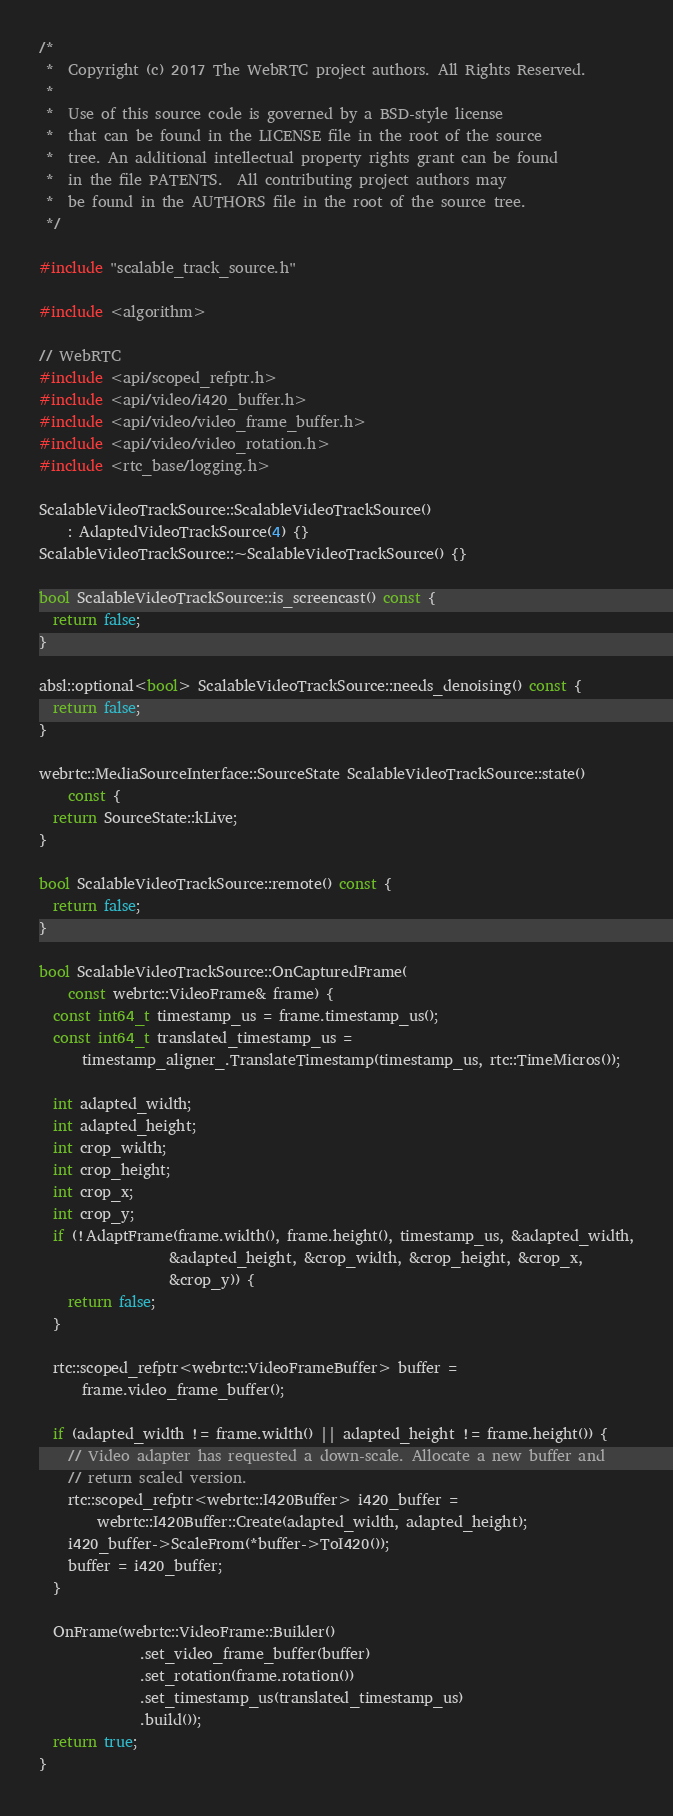Convert code to text. <code><loc_0><loc_0><loc_500><loc_500><_C++_>/*
 *  Copyright (c) 2017 The WebRTC project authors. All Rights Reserved.
 *
 *  Use of this source code is governed by a BSD-style license
 *  that can be found in the LICENSE file in the root of the source
 *  tree. An additional intellectual property rights grant can be found
 *  in the file PATENTS.  All contributing project authors may
 *  be found in the AUTHORS file in the root of the source tree.
 */

#include "scalable_track_source.h"

#include <algorithm>

// WebRTC
#include <api/scoped_refptr.h>
#include <api/video/i420_buffer.h>
#include <api/video/video_frame_buffer.h>
#include <api/video/video_rotation.h>
#include <rtc_base/logging.h>

ScalableVideoTrackSource::ScalableVideoTrackSource()
    : AdaptedVideoTrackSource(4) {}
ScalableVideoTrackSource::~ScalableVideoTrackSource() {}

bool ScalableVideoTrackSource::is_screencast() const {
  return false;
}

absl::optional<bool> ScalableVideoTrackSource::needs_denoising() const {
  return false;
}

webrtc::MediaSourceInterface::SourceState ScalableVideoTrackSource::state()
    const {
  return SourceState::kLive;
}

bool ScalableVideoTrackSource::remote() const {
  return false;
}

bool ScalableVideoTrackSource::OnCapturedFrame(
    const webrtc::VideoFrame& frame) {
  const int64_t timestamp_us = frame.timestamp_us();
  const int64_t translated_timestamp_us =
      timestamp_aligner_.TranslateTimestamp(timestamp_us, rtc::TimeMicros());

  int adapted_width;
  int adapted_height;
  int crop_width;
  int crop_height;
  int crop_x;
  int crop_y;
  if (!AdaptFrame(frame.width(), frame.height(), timestamp_us, &adapted_width,
                  &adapted_height, &crop_width, &crop_height, &crop_x,
                  &crop_y)) {
    return false;
  }

  rtc::scoped_refptr<webrtc::VideoFrameBuffer> buffer =
      frame.video_frame_buffer();

  if (adapted_width != frame.width() || adapted_height != frame.height()) {
    // Video adapter has requested a down-scale. Allocate a new buffer and
    // return scaled version.
    rtc::scoped_refptr<webrtc::I420Buffer> i420_buffer =
        webrtc::I420Buffer::Create(adapted_width, adapted_height);
    i420_buffer->ScaleFrom(*buffer->ToI420());
    buffer = i420_buffer;
  }

  OnFrame(webrtc::VideoFrame::Builder()
              .set_video_frame_buffer(buffer)
              .set_rotation(frame.rotation())
              .set_timestamp_us(translated_timestamp_us)
              .build());
  return true;
}
</code> 